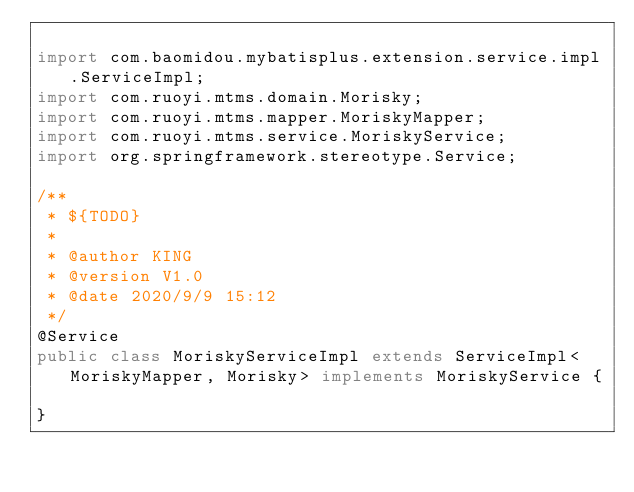Convert code to text. <code><loc_0><loc_0><loc_500><loc_500><_Java_>
import com.baomidou.mybatisplus.extension.service.impl.ServiceImpl;
import com.ruoyi.mtms.domain.Morisky;
import com.ruoyi.mtms.mapper.MoriskyMapper;
import com.ruoyi.mtms.service.MoriskyService;
import org.springframework.stereotype.Service;

/**
 * ${TODO}
 *
 * @author KING
 * @version V1.0
 * @date 2020/9/9 15:12
 */
@Service
public class MoriskyServiceImpl extends ServiceImpl<MoriskyMapper, Morisky> implements MoriskyService {

}


</code> 